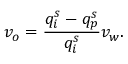Convert formula to latex. <formula><loc_0><loc_0><loc_500><loc_500>v _ { o } = \frac { q _ { i } ^ { s } - q _ { p } ^ { s } } { q _ { i } ^ { s } } v _ { w } .</formula> 